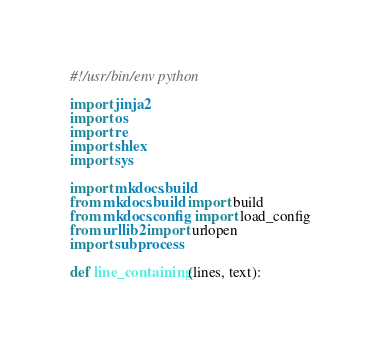Convert code to text. <code><loc_0><loc_0><loc_500><loc_500><_Python_>#!/usr/bin/env python

import jinja2
import os
import re
import shlex
import sys

import mkdocs.build
from mkdocs.build import build
from mkdocs.config import load_config
from urllib2 import urlopen
import subprocess

def line_containing(lines, text):</code> 